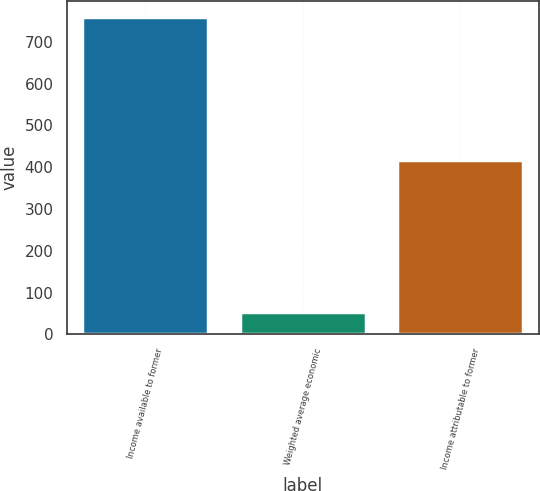Convert chart. <chart><loc_0><loc_0><loc_500><loc_500><bar_chart><fcel>Income available to former<fcel>Weighted average economic<fcel>Income attributable to former<nl><fcel>760<fcel>54.8<fcel>416<nl></chart> 